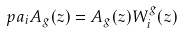<formula> <loc_0><loc_0><loc_500><loc_500>\ p a _ { i } A _ { g } ( z ) = A _ { g } ( z ) W _ { i } ^ { g } ( z )</formula> 